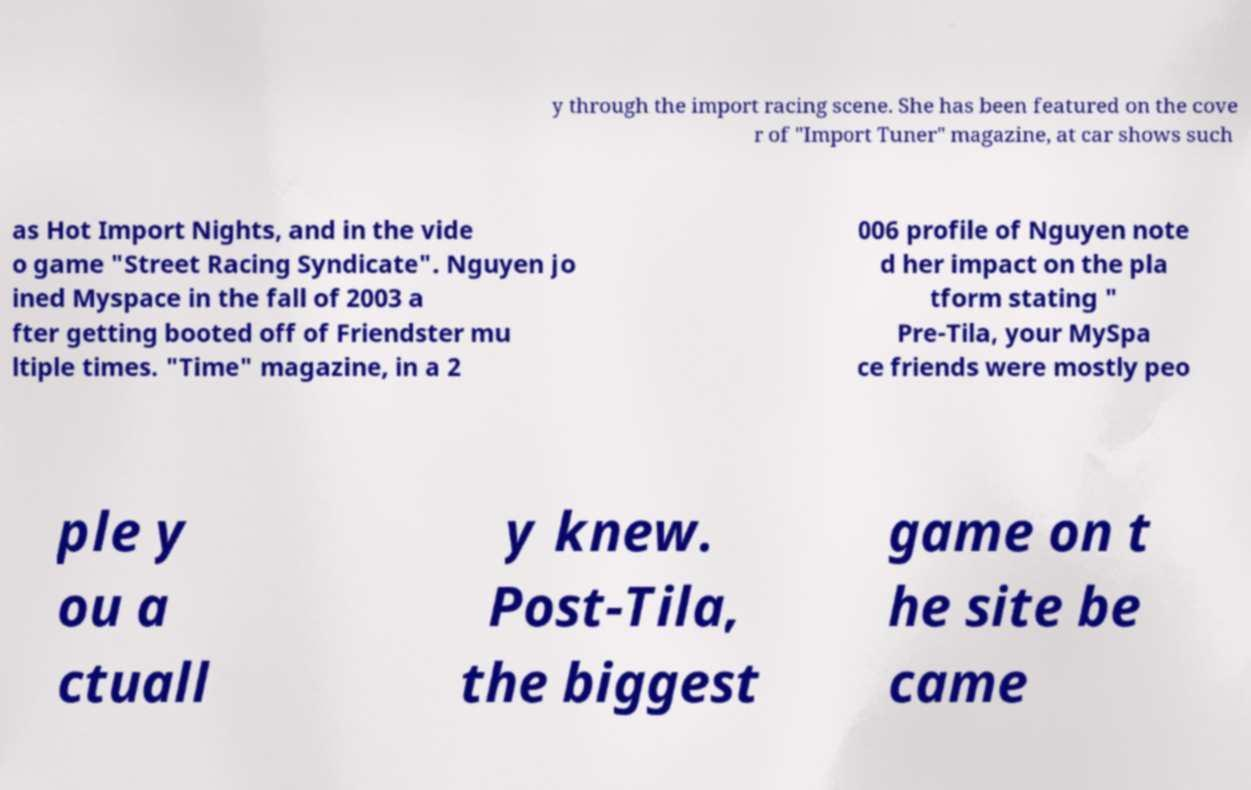There's text embedded in this image that I need extracted. Can you transcribe it verbatim? y through the import racing scene. She has been featured on the cove r of "Import Tuner" magazine, at car shows such as Hot Import Nights, and in the vide o game "Street Racing Syndicate". Nguyen jo ined Myspace in the fall of 2003 a fter getting booted off of Friendster mu ltiple times. "Time" magazine, in a 2 006 profile of Nguyen note d her impact on the pla tform stating " Pre-Tila, your MySpa ce friends were mostly peo ple y ou a ctuall y knew. Post-Tila, the biggest game on t he site be came 